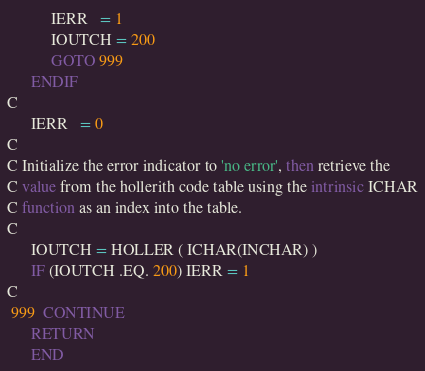<code> <loc_0><loc_0><loc_500><loc_500><_FORTRAN_>           IERR   = 1
           IOUTCH = 200
           GOTO 999
      ENDIF
C
      IERR   = 0
C
C Initialize the error indicator to 'no error', then retrieve the
C value from the hollerith code table using the intrinsic ICHAR
C function as an index into the table.
C
      IOUTCH = HOLLER ( ICHAR(INCHAR) )
      IF (IOUTCH .EQ. 200) IERR = 1
C
 999  CONTINUE
      RETURN
      END
</code> 